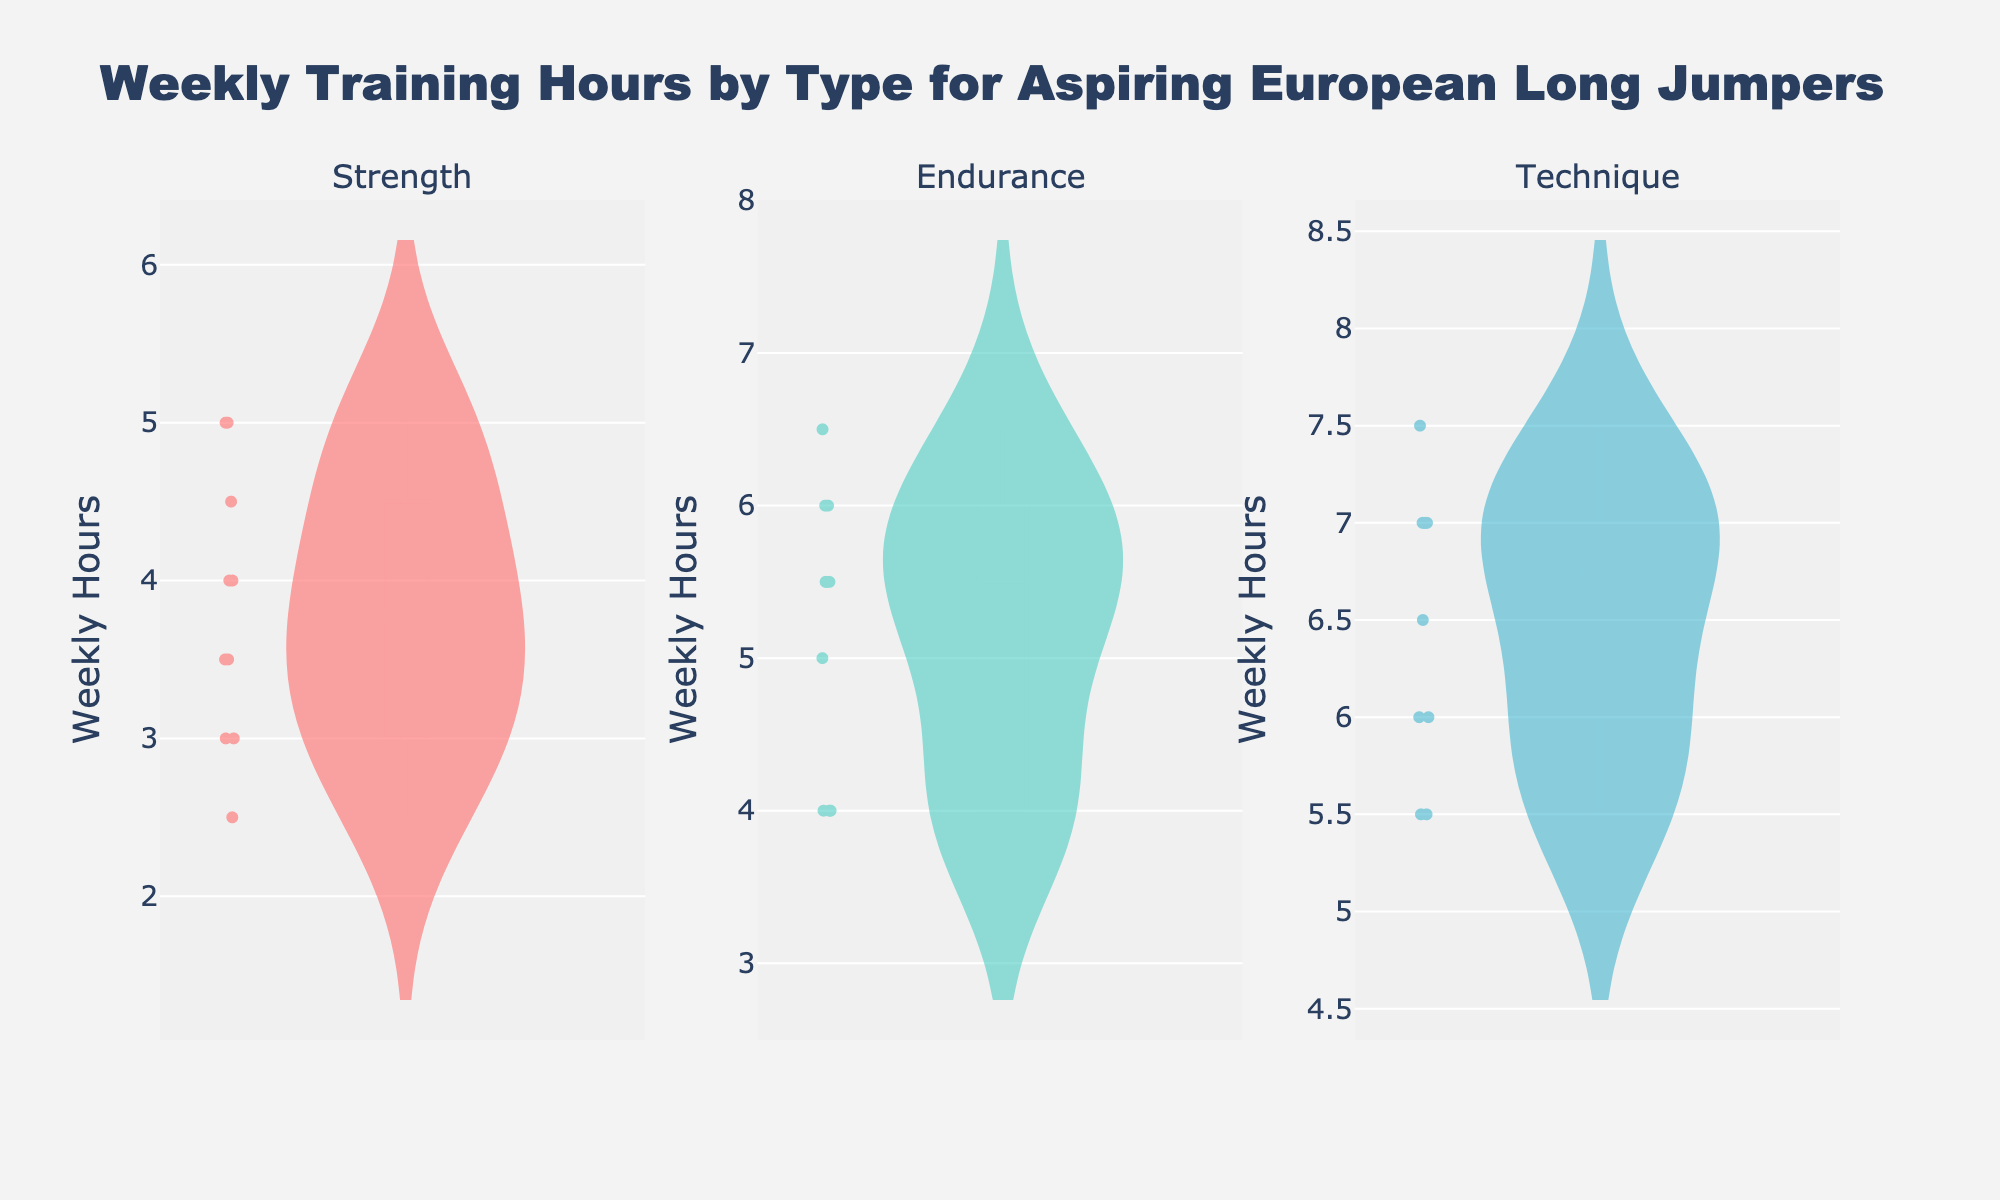How many subplots does the figure contain? The figure includes separate violin plots for each type of training. By looking at the different plots, you can see there is one for Strength, one for Endurance, and one for Technique.
Answer: 3 Which training type has the highest mean weekly training hours? Each of the violin plots has a meanline visible. Among Strength, Endurance, and Technique, the meanline in the Technique subplot appears to be the highest.
Answer: Technique What is the range of weekly training hours in the Endurance training type? To find the range, we look at the highest and lowest points of the distribution in the Endurance subplot. The lowest appears around 4.0 hours and the highest around 6.5 hours.
Answer: 4.0 to 6.5 hours Which training type seems to have the most variation in weekly hours? Variation can be judged by the spread of the values in the violin plots. The Technique plot shows the widest spread of points compared to Strength and Endurance.
Answer: Technique How does the median weekly training hours of Strength compare with that of Endurance? By examining the horizontal lines within each violin plot, the median of Strength is around 3.5-4.0 hours, and the median of Endurance is around 5.0-5.5 hours. The Endurance median is higher.
Answer: Endurance has a higher median Is the median weekly training hours for Technique higher or lower than for Strength? The median is indicated by a line in the center of each violin plot. The line for Technique is higher up than the line for Strength.
Answer: Higher Which training type has the least spread in weekly training hours? The spread can be evaluated by the width of the violin plots. Strength appears to be the narrowest, indicating the least variation.
Answer: Strength How many hours of weekly training does the median in Technique represent? The median line in the Technique violin plot represents the midpoint of the data. It is positioned around 6.5 hours.
Answer: 6.5 hours What color represents the Endurance training type? By observing the colors used in the violin plots, Endurance is represented by a green-blue hue.
Answer: Green-blue 